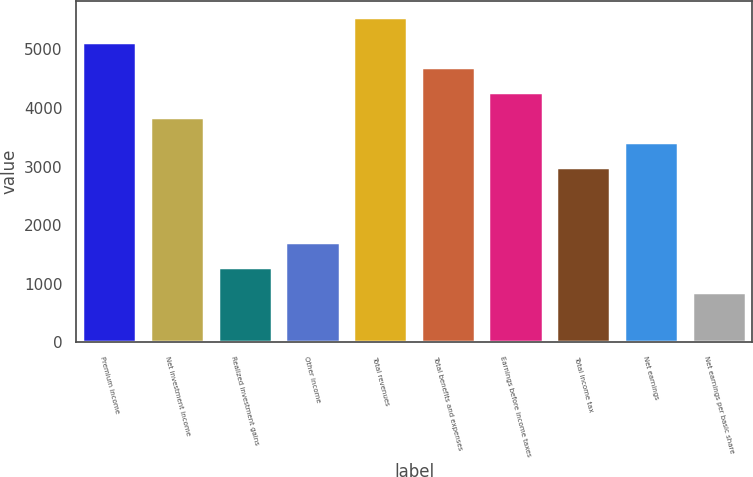<chart> <loc_0><loc_0><loc_500><loc_500><bar_chart><fcel>Premium income<fcel>Net investment income<fcel>Realized investment gains<fcel>Other income<fcel>Total revenues<fcel>Total benefits and expenses<fcel>Earnings before income taxes<fcel>Total income tax<fcel>Net earnings<fcel>Net earnings per basic share<nl><fcel>5120.4<fcel>3840.36<fcel>1280.28<fcel>1706.96<fcel>5547.08<fcel>4693.72<fcel>4267.04<fcel>2987<fcel>3413.68<fcel>853.6<nl></chart> 